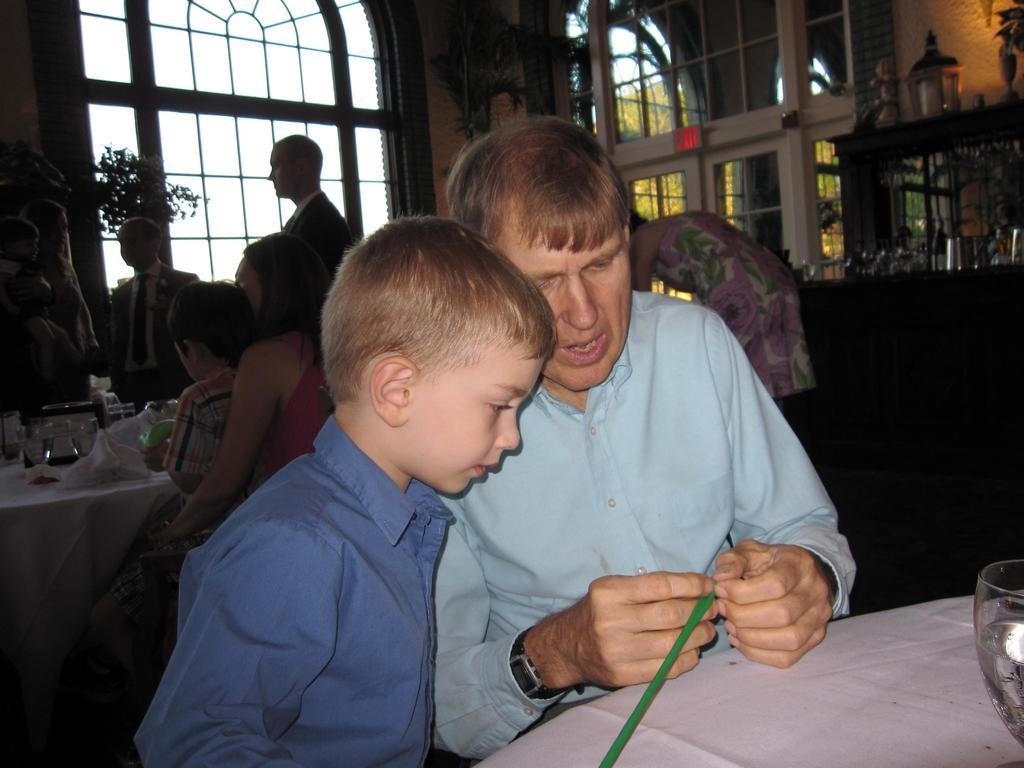Who is present in the image? There is a man and a boy in the image. How are the man and the boy positioned in relation to each other? The boy is beside the man. What is the setting of the image? The scene appears to be in a restaurant. What is on the table in the image? The table has food and glasses on it. What type of writer is sitting at the table in the image? There is no writer present in the image; it only shows a man and a boy. Can you see a needle on the table in the image? No, there is no needle visible on the table in the image. 